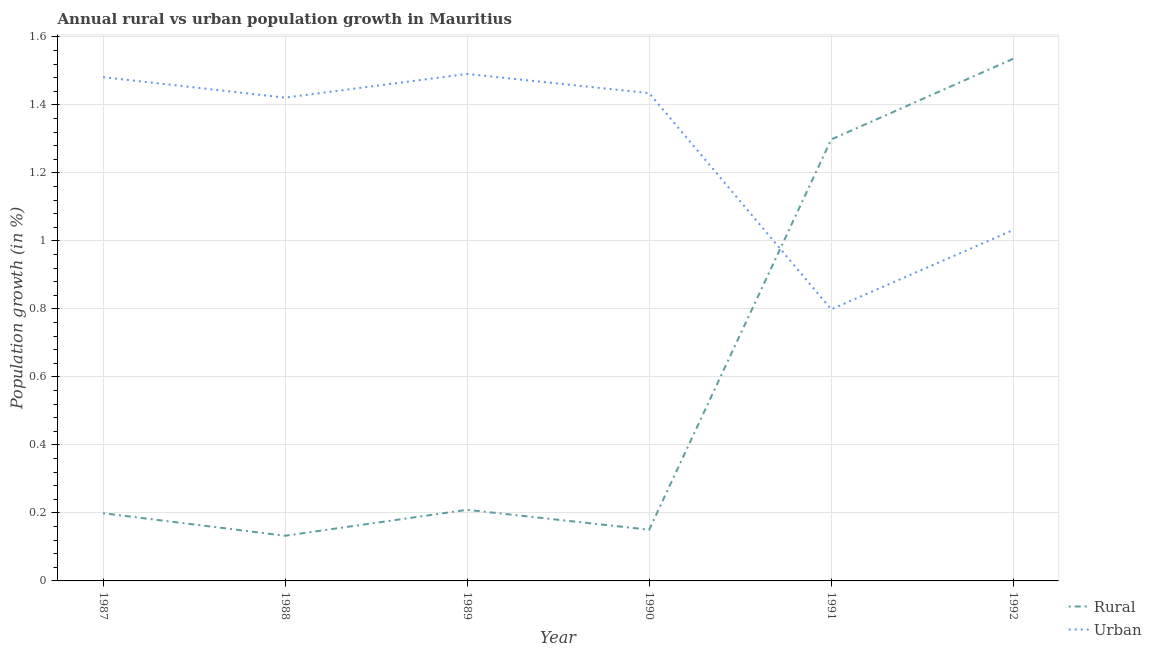How many different coloured lines are there?
Ensure brevity in your answer.  2. Is the number of lines equal to the number of legend labels?
Provide a succinct answer. Yes. What is the rural population growth in 1989?
Make the answer very short. 0.21. Across all years, what is the maximum rural population growth?
Provide a succinct answer. 1.54. Across all years, what is the minimum rural population growth?
Your response must be concise. 0.13. In which year was the rural population growth minimum?
Your answer should be very brief. 1988. What is the total urban population growth in the graph?
Ensure brevity in your answer.  7.66. What is the difference between the urban population growth in 1989 and that in 1992?
Offer a terse response. 0.46. What is the difference between the urban population growth in 1988 and the rural population growth in 1992?
Provide a short and direct response. -0.11. What is the average urban population growth per year?
Your answer should be compact. 1.28. In the year 1988, what is the difference between the rural population growth and urban population growth?
Provide a short and direct response. -1.29. In how many years, is the urban population growth greater than 0.92 %?
Provide a short and direct response. 5. What is the ratio of the urban population growth in 1990 to that in 1991?
Give a very brief answer. 1.8. Is the difference between the rural population growth in 1987 and 1990 greater than the difference between the urban population growth in 1987 and 1990?
Offer a terse response. Yes. What is the difference between the highest and the second highest urban population growth?
Offer a very short reply. 0.01. What is the difference between the highest and the lowest rural population growth?
Offer a very short reply. 1.4. Does the urban population growth monotonically increase over the years?
Give a very brief answer. No. Is the rural population growth strictly greater than the urban population growth over the years?
Provide a succinct answer. No. Is the urban population growth strictly less than the rural population growth over the years?
Give a very brief answer. No. Are the values on the major ticks of Y-axis written in scientific E-notation?
Ensure brevity in your answer.  No. Does the graph contain any zero values?
Provide a succinct answer. No. Does the graph contain grids?
Offer a very short reply. Yes. Where does the legend appear in the graph?
Provide a short and direct response. Bottom right. How many legend labels are there?
Give a very brief answer. 2. What is the title of the graph?
Your answer should be compact. Annual rural vs urban population growth in Mauritius. Does "Commercial bank branches" appear as one of the legend labels in the graph?
Offer a very short reply. No. What is the label or title of the Y-axis?
Offer a terse response. Population growth (in %). What is the Population growth (in %) in Rural in 1987?
Keep it short and to the point. 0.2. What is the Population growth (in %) of Urban  in 1987?
Your answer should be very brief. 1.48. What is the Population growth (in %) in Rural in 1988?
Ensure brevity in your answer.  0.13. What is the Population growth (in %) in Urban  in 1988?
Make the answer very short. 1.42. What is the Population growth (in %) in Rural in 1989?
Ensure brevity in your answer.  0.21. What is the Population growth (in %) of Urban  in 1989?
Provide a succinct answer. 1.49. What is the Population growth (in %) in Rural in 1990?
Provide a short and direct response. 0.15. What is the Population growth (in %) in Urban  in 1990?
Make the answer very short. 1.43. What is the Population growth (in %) of Rural in 1991?
Provide a short and direct response. 1.3. What is the Population growth (in %) in Urban  in 1991?
Give a very brief answer. 0.8. What is the Population growth (in %) in Rural in 1992?
Offer a very short reply. 1.54. What is the Population growth (in %) in Urban  in 1992?
Your response must be concise. 1.03. Across all years, what is the maximum Population growth (in %) of Rural?
Make the answer very short. 1.54. Across all years, what is the maximum Population growth (in %) in Urban ?
Your answer should be compact. 1.49. Across all years, what is the minimum Population growth (in %) in Rural?
Give a very brief answer. 0.13. Across all years, what is the minimum Population growth (in %) in Urban ?
Your answer should be very brief. 0.8. What is the total Population growth (in %) in Rural in the graph?
Your answer should be very brief. 3.53. What is the total Population growth (in %) of Urban  in the graph?
Offer a terse response. 7.66. What is the difference between the Population growth (in %) of Rural in 1987 and that in 1988?
Give a very brief answer. 0.07. What is the difference between the Population growth (in %) in Urban  in 1987 and that in 1988?
Give a very brief answer. 0.06. What is the difference between the Population growth (in %) in Rural in 1987 and that in 1989?
Provide a succinct answer. -0.01. What is the difference between the Population growth (in %) in Urban  in 1987 and that in 1989?
Ensure brevity in your answer.  -0.01. What is the difference between the Population growth (in %) of Rural in 1987 and that in 1990?
Your answer should be very brief. 0.05. What is the difference between the Population growth (in %) of Urban  in 1987 and that in 1990?
Keep it short and to the point. 0.05. What is the difference between the Population growth (in %) of Rural in 1987 and that in 1991?
Provide a succinct answer. -1.1. What is the difference between the Population growth (in %) of Urban  in 1987 and that in 1991?
Give a very brief answer. 0.68. What is the difference between the Population growth (in %) of Rural in 1987 and that in 1992?
Your answer should be compact. -1.34. What is the difference between the Population growth (in %) of Urban  in 1987 and that in 1992?
Give a very brief answer. 0.45. What is the difference between the Population growth (in %) in Rural in 1988 and that in 1989?
Offer a terse response. -0.08. What is the difference between the Population growth (in %) of Urban  in 1988 and that in 1989?
Your response must be concise. -0.07. What is the difference between the Population growth (in %) of Rural in 1988 and that in 1990?
Your answer should be compact. -0.02. What is the difference between the Population growth (in %) of Urban  in 1988 and that in 1990?
Provide a short and direct response. -0.01. What is the difference between the Population growth (in %) in Rural in 1988 and that in 1991?
Offer a very short reply. -1.17. What is the difference between the Population growth (in %) in Urban  in 1988 and that in 1991?
Your answer should be compact. 0.62. What is the difference between the Population growth (in %) in Rural in 1988 and that in 1992?
Keep it short and to the point. -1.4. What is the difference between the Population growth (in %) in Urban  in 1988 and that in 1992?
Offer a very short reply. 0.39. What is the difference between the Population growth (in %) in Rural in 1989 and that in 1990?
Give a very brief answer. 0.06. What is the difference between the Population growth (in %) in Urban  in 1989 and that in 1990?
Offer a terse response. 0.06. What is the difference between the Population growth (in %) of Rural in 1989 and that in 1991?
Ensure brevity in your answer.  -1.09. What is the difference between the Population growth (in %) in Urban  in 1989 and that in 1991?
Offer a very short reply. 0.69. What is the difference between the Population growth (in %) of Rural in 1989 and that in 1992?
Give a very brief answer. -1.33. What is the difference between the Population growth (in %) in Urban  in 1989 and that in 1992?
Offer a terse response. 0.46. What is the difference between the Population growth (in %) of Rural in 1990 and that in 1991?
Make the answer very short. -1.15. What is the difference between the Population growth (in %) of Urban  in 1990 and that in 1991?
Keep it short and to the point. 0.64. What is the difference between the Population growth (in %) of Rural in 1990 and that in 1992?
Give a very brief answer. -1.39. What is the difference between the Population growth (in %) of Urban  in 1990 and that in 1992?
Ensure brevity in your answer.  0.4. What is the difference between the Population growth (in %) of Rural in 1991 and that in 1992?
Make the answer very short. -0.24. What is the difference between the Population growth (in %) of Urban  in 1991 and that in 1992?
Offer a very short reply. -0.23. What is the difference between the Population growth (in %) in Rural in 1987 and the Population growth (in %) in Urban  in 1988?
Provide a succinct answer. -1.22. What is the difference between the Population growth (in %) in Rural in 1987 and the Population growth (in %) in Urban  in 1989?
Provide a short and direct response. -1.29. What is the difference between the Population growth (in %) of Rural in 1987 and the Population growth (in %) of Urban  in 1990?
Offer a terse response. -1.24. What is the difference between the Population growth (in %) of Rural in 1987 and the Population growth (in %) of Urban  in 1991?
Offer a very short reply. -0.6. What is the difference between the Population growth (in %) in Rural in 1987 and the Population growth (in %) in Urban  in 1992?
Your answer should be very brief. -0.83. What is the difference between the Population growth (in %) of Rural in 1988 and the Population growth (in %) of Urban  in 1989?
Your answer should be very brief. -1.36. What is the difference between the Population growth (in %) of Rural in 1988 and the Population growth (in %) of Urban  in 1990?
Ensure brevity in your answer.  -1.3. What is the difference between the Population growth (in %) in Rural in 1988 and the Population growth (in %) in Urban  in 1991?
Make the answer very short. -0.67. What is the difference between the Population growth (in %) in Rural in 1988 and the Population growth (in %) in Urban  in 1992?
Your answer should be compact. -0.9. What is the difference between the Population growth (in %) in Rural in 1989 and the Population growth (in %) in Urban  in 1990?
Provide a short and direct response. -1.23. What is the difference between the Population growth (in %) in Rural in 1989 and the Population growth (in %) in Urban  in 1991?
Your answer should be compact. -0.59. What is the difference between the Population growth (in %) in Rural in 1989 and the Population growth (in %) in Urban  in 1992?
Provide a short and direct response. -0.82. What is the difference between the Population growth (in %) in Rural in 1990 and the Population growth (in %) in Urban  in 1991?
Offer a terse response. -0.65. What is the difference between the Population growth (in %) of Rural in 1990 and the Population growth (in %) of Urban  in 1992?
Your answer should be compact. -0.88. What is the difference between the Population growth (in %) in Rural in 1991 and the Population growth (in %) in Urban  in 1992?
Make the answer very short. 0.27. What is the average Population growth (in %) in Rural per year?
Ensure brevity in your answer.  0.59. What is the average Population growth (in %) of Urban  per year?
Offer a terse response. 1.28. In the year 1987, what is the difference between the Population growth (in %) of Rural and Population growth (in %) of Urban ?
Provide a succinct answer. -1.28. In the year 1988, what is the difference between the Population growth (in %) of Rural and Population growth (in %) of Urban ?
Ensure brevity in your answer.  -1.29. In the year 1989, what is the difference between the Population growth (in %) in Rural and Population growth (in %) in Urban ?
Your answer should be compact. -1.28. In the year 1990, what is the difference between the Population growth (in %) of Rural and Population growth (in %) of Urban ?
Offer a terse response. -1.28. In the year 1991, what is the difference between the Population growth (in %) in Rural and Population growth (in %) in Urban ?
Your answer should be compact. 0.5. In the year 1992, what is the difference between the Population growth (in %) in Rural and Population growth (in %) in Urban ?
Your answer should be very brief. 0.5. What is the ratio of the Population growth (in %) of Rural in 1987 to that in 1988?
Make the answer very short. 1.5. What is the ratio of the Population growth (in %) in Urban  in 1987 to that in 1988?
Your response must be concise. 1.04. What is the ratio of the Population growth (in %) of Rural in 1987 to that in 1989?
Your response must be concise. 0.95. What is the ratio of the Population growth (in %) in Urban  in 1987 to that in 1989?
Provide a succinct answer. 0.99. What is the ratio of the Population growth (in %) of Rural in 1987 to that in 1990?
Offer a very short reply. 1.32. What is the ratio of the Population growth (in %) in Urban  in 1987 to that in 1990?
Keep it short and to the point. 1.03. What is the ratio of the Population growth (in %) of Rural in 1987 to that in 1991?
Keep it short and to the point. 0.15. What is the ratio of the Population growth (in %) of Urban  in 1987 to that in 1991?
Provide a short and direct response. 1.85. What is the ratio of the Population growth (in %) in Rural in 1987 to that in 1992?
Your answer should be very brief. 0.13. What is the ratio of the Population growth (in %) in Urban  in 1987 to that in 1992?
Provide a succinct answer. 1.44. What is the ratio of the Population growth (in %) of Rural in 1988 to that in 1989?
Your response must be concise. 0.64. What is the ratio of the Population growth (in %) in Urban  in 1988 to that in 1989?
Provide a short and direct response. 0.95. What is the ratio of the Population growth (in %) in Rural in 1988 to that in 1990?
Make the answer very short. 0.88. What is the ratio of the Population growth (in %) in Rural in 1988 to that in 1991?
Ensure brevity in your answer.  0.1. What is the ratio of the Population growth (in %) of Urban  in 1988 to that in 1991?
Offer a terse response. 1.78. What is the ratio of the Population growth (in %) of Rural in 1988 to that in 1992?
Offer a very short reply. 0.09. What is the ratio of the Population growth (in %) in Urban  in 1988 to that in 1992?
Ensure brevity in your answer.  1.38. What is the ratio of the Population growth (in %) of Rural in 1989 to that in 1990?
Your response must be concise. 1.39. What is the ratio of the Population growth (in %) of Urban  in 1989 to that in 1990?
Your answer should be compact. 1.04. What is the ratio of the Population growth (in %) in Rural in 1989 to that in 1991?
Provide a short and direct response. 0.16. What is the ratio of the Population growth (in %) of Urban  in 1989 to that in 1991?
Offer a terse response. 1.87. What is the ratio of the Population growth (in %) of Rural in 1989 to that in 1992?
Provide a succinct answer. 0.14. What is the ratio of the Population growth (in %) in Urban  in 1989 to that in 1992?
Provide a short and direct response. 1.44. What is the ratio of the Population growth (in %) in Rural in 1990 to that in 1991?
Offer a very short reply. 0.12. What is the ratio of the Population growth (in %) in Urban  in 1990 to that in 1991?
Offer a very short reply. 1.8. What is the ratio of the Population growth (in %) in Rural in 1990 to that in 1992?
Provide a succinct answer. 0.1. What is the ratio of the Population growth (in %) in Urban  in 1990 to that in 1992?
Make the answer very short. 1.39. What is the ratio of the Population growth (in %) of Rural in 1991 to that in 1992?
Provide a succinct answer. 0.85. What is the ratio of the Population growth (in %) of Urban  in 1991 to that in 1992?
Your answer should be very brief. 0.77. What is the difference between the highest and the second highest Population growth (in %) in Rural?
Provide a short and direct response. 0.24. What is the difference between the highest and the second highest Population growth (in %) of Urban ?
Your answer should be very brief. 0.01. What is the difference between the highest and the lowest Population growth (in %) in Rural?
Ensure brevity in your answer.  1.4. What is the difference between the highest and the lowest Population growth (in %) in Urban ?
Offer a very short reply. 0.69. 